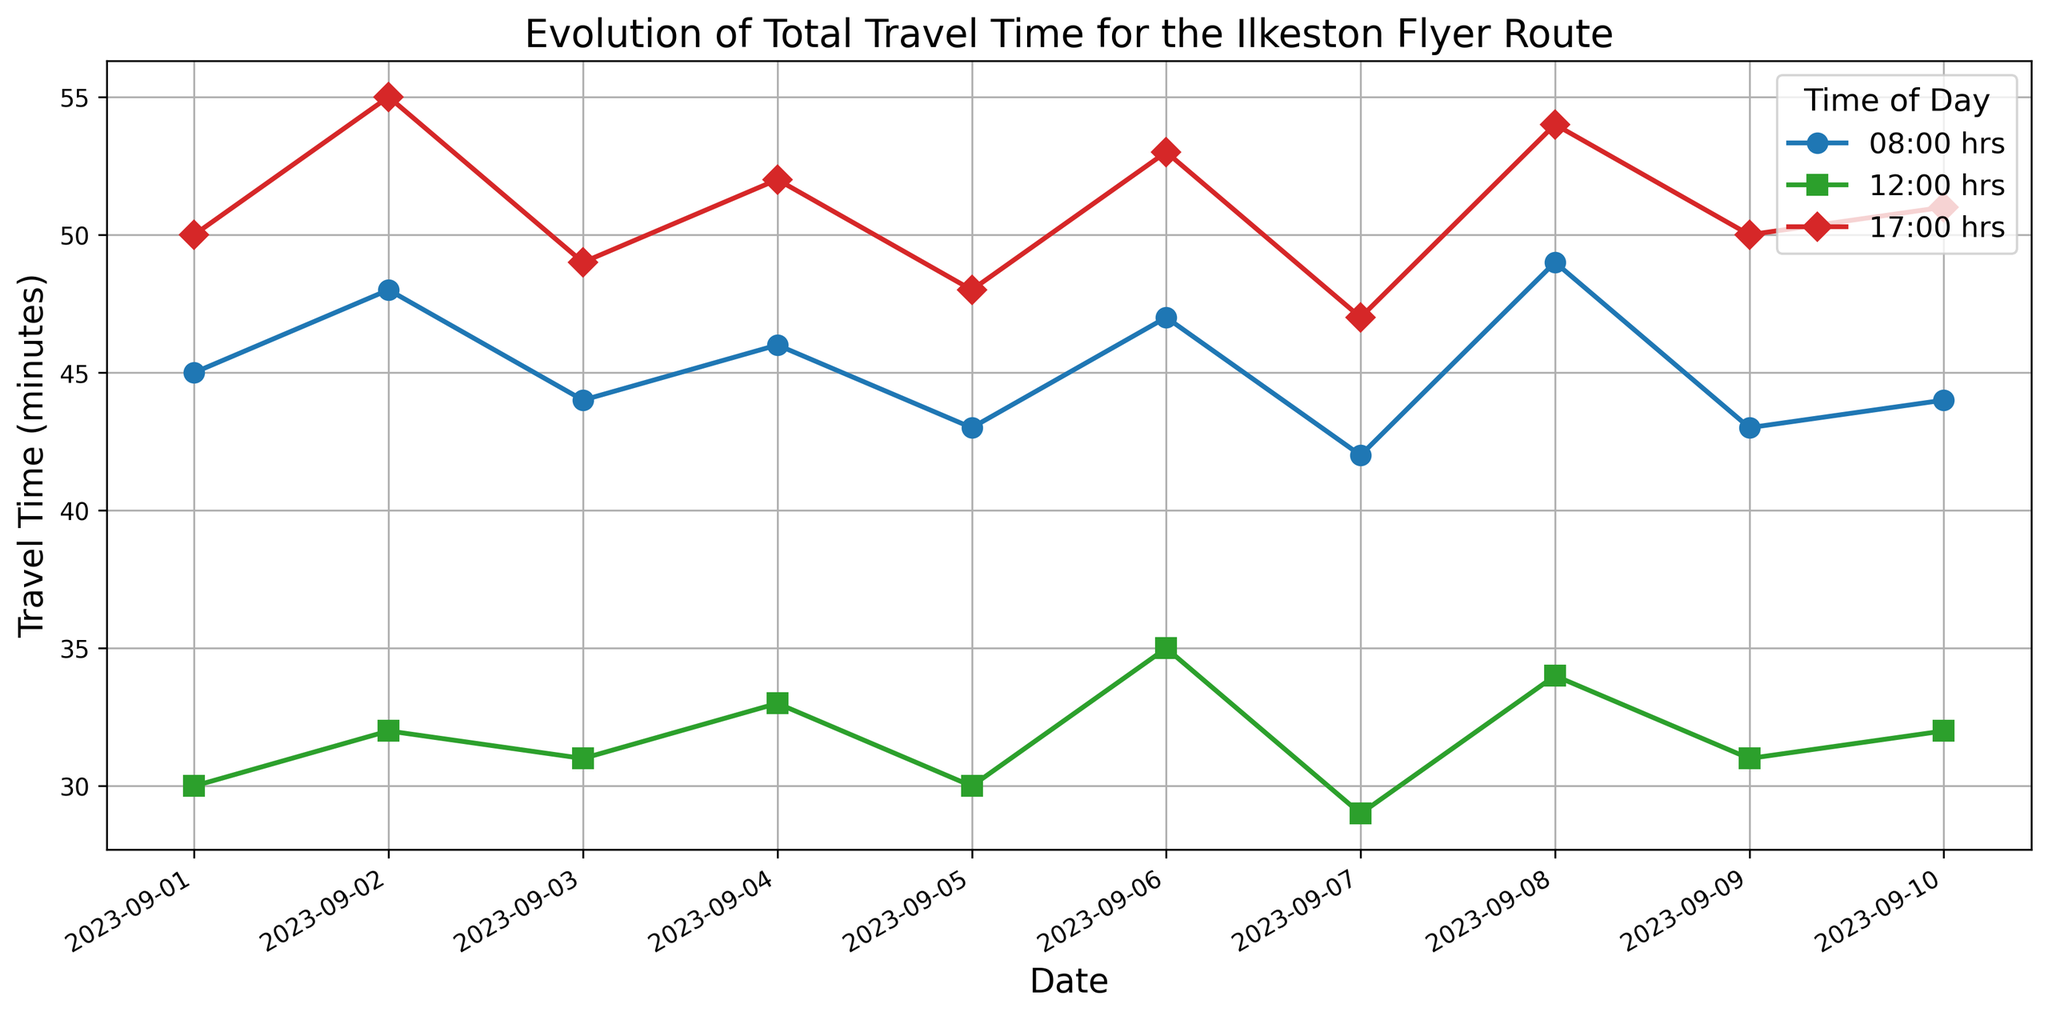When did the travel time at 17:00 hrs first reach 55 minutes? Identify the 17:00 hrs curve and look for the first date where it reaches 55 minutes. The first occurrence is on 2023-09-02.
Answer: 2023-09-02 Which time of day generally has the lowest travel time? Compare the travel time for 08:00, 12:00, and 17:00 hrs across all dates. The 12:00 hrs curve generally has the lowest travel times.
Answer: 12:00 hrs What is the average travel time at 08:00 hrs over the displayed period? Sum up the travel times at 08:00 hrs for all dates and divide by the number of days. Sum = 45+48+44+46+43+47+42+49+43+44 = 451. Average = 451/10 = 45.1
Answer: 45.1 minutes On which date does the 12:00 hrs travel time hit its minimum value, and what is that value? Find the lowest point on the 12:00 hrs curve and note the date and value. The minimum value of 29 minutes occurs on 2023-09-07.
Answer: 2023-09-07, 29 minutes How does the travel time at 08:00 hrs on 2023-09-01 compare to that on 2023-09-10? Locate the travel times at 08:00 hrs for both dates and compare them. 2023-09-01 has 45 minutes, and 2023-09-10 has 44 minutes.
Answer: 2023-09-01 is 1 minute higher than 2023-09-10 What is the difference in travel time between peak (17:00 hrs) and non-peak (12:00 hrs) on 2023-09-04? Compute the difference between travel times at 17:00 hrs and 12:00 hrs on 2023-09-04. Difference = 52 - 33 = 19 minutes.
Answer: 19 minutes Which date has the smallest gap between travel times at 08:00 and 17:00 hrs? Calculate the gap between 08:00 and 17:00 hrs for each date and find the smallest one. The smallest gap of 3 minutes occurs on 2023-09-01 (45 at 08:00 and 50 at 17:00).
Answer: 2023-09-01 What is the trend of travel times at 17:00 hrs from 2023-09-01 to 2023-09-10? Observe the 17:00 hrs curve from start to end date. The trend shows a general increase in travel time over this period.
Answer: Increasing On which date is the travel time at 12:00 hrs greater than both 08:00 and 17:00 hrs? Check each date and compare the travel times at all three hours. It never happens in the given dates as 12:00 hrs is always lesser than either 08:00 or 17:00 hrs.
Answer: It never happens 